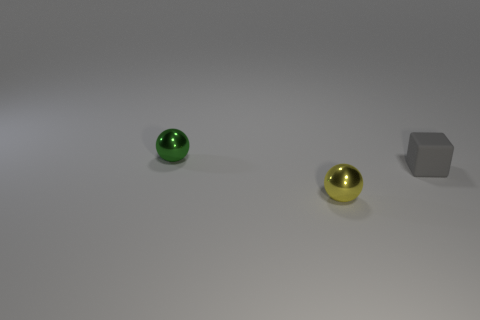What number of other things are the same material as the small yellow ball?
Keep it short and to the point. 1. Is there anything else that is the same shape as the gray thing?
Provide a succinct answer. No. There is a tiny metal object behind the shiny sphere in front of the tiny thing behind the gray rubber cube; what is its color?
Provide a succinct answer. Green. What shape is the thing that is both to the left of the gray matte thing and behind the small yellow object?
Make the answer very short. Sphere. There is a metallic thing behind the metal object to the right of the tiny green shiny sphere; what color is it?
Offer a terse response. Green. There is a shiny object that is in front of the object to the left of the small shiny sphere that is in front of the tiny gray object; what is its shape?
Provide a succinct answer. Sphere. What number of objects are the same color as the matte cube?
Your response must be concise. 0. What material is the gray object?
Your answer should be very brief. Rubber. Is the thing behind the tiny gray matte cube made of the same material as the gray object?
Offer a very short reply. No. There is a object that is behind the tiny gray cube; what shape is it?
Make the answer very short. Sphere. 